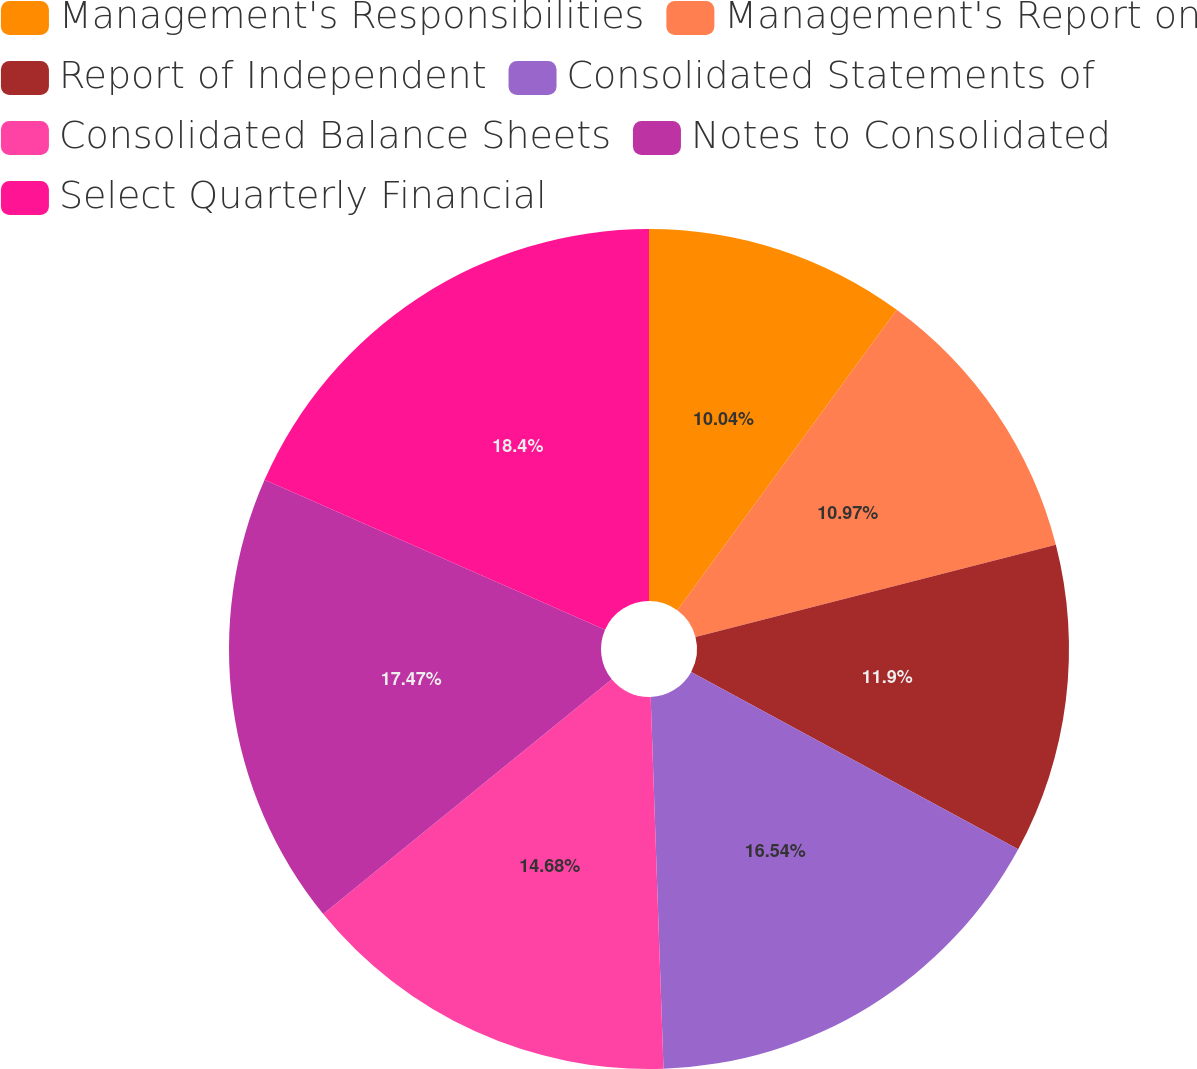Convert chart. <chart><loc_0><loc_0><loc_500><loc_500><pie_chart><fcel>Management's Responsibilities<fcel>Management's Report on<fcel>Report of Independent<fcel>Consolidated Statements of<fcel>Consolidated Balance Sheets<fcel>Notes to Consolidated<fcel>Select Quarterly Financial<nl><fcel>10.04%<fcel>10.97%<fcel>11.9%<fcel>16.54%<fcel>14.68%<fcel>17.47%<fcel>18.4%<nl></chart> 